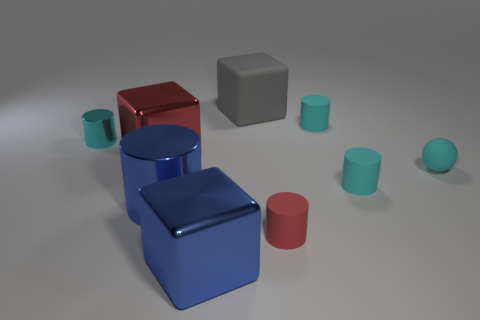Subtract all cyan cylinders. How many were subtracted if there are1cyan cylinders left? 2 Subtract all blue blocks. How many cyan cylinders are left? 3 Subtract all red cylinders. How many cylinders are left? 4 Subtract all red cylinders. How many cylinders are left? 4 Subtract all green cylinders. Subtract all red blocks. How many cylinders are left? 5 Subtract all cubes. How many objects are left? 6 Add 9 gray blocks. How many gray blocks exist? 10 Subtract 0 cyan blocks. How many objects are left? 9 Subtract all red objects. Subtract all matte blocks. How many objects are left? 6 Add 6 gray matte things. How many gray matte things are left? 7 